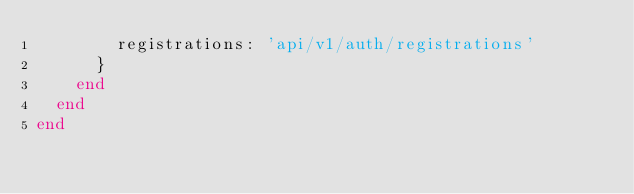Convert code to text. <code><loc_0><loc_0><loc_500><loc_500><_Ruby_>        registrations: 'api/v1/auth/registrations'
      }
    end
  end
end</code> 